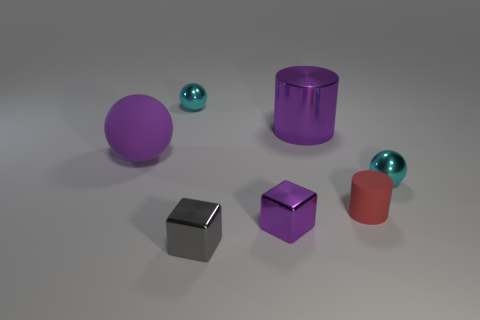Subtract 1 balls. How many balls are left? 2 Add 3 small purple spheres. How many objects exist? 10 Subtract all cylinders. How many objects are left? 5 Add 5 large shiny things. How many large shiny things are left? 6 Add 5 tiny cyan balls. How many tiny cyan balls exist? 7 Subtract 0 green cubes. How many objects are left? 7 Subtract all tiny brown matte cubes. Subtract all cyan metal balls. How many objects are left? 5 